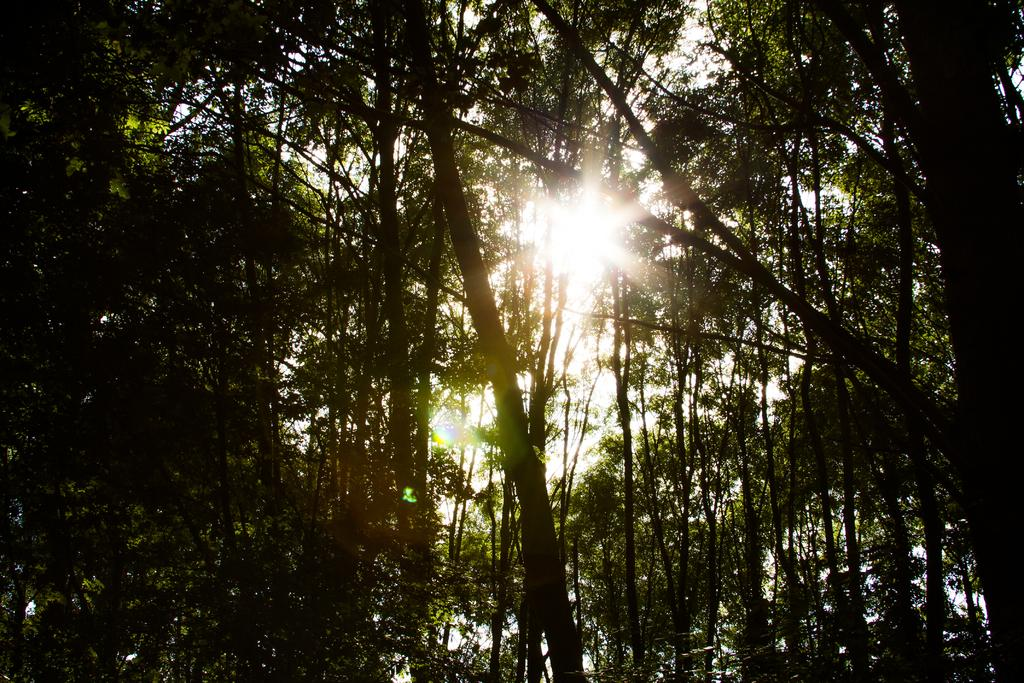Where was the image taken? The image was taken outdoors. What can be seen in the background of the image? There is sky visible in the background of the image. What is the condition of the sky in the image? The sun is present in the sky. What type of vegetation is in the middle of the image? There are trees with leaves, stems, and branches in the middle of the image. Can you see any birds fighting in the image? There are no birds present in the image, and therefore no fighting can be observed. What type of work is being done by the trees in the image? Trees do not perform work; they are living organisms that provide oxygen and serve as habitats for various species. 